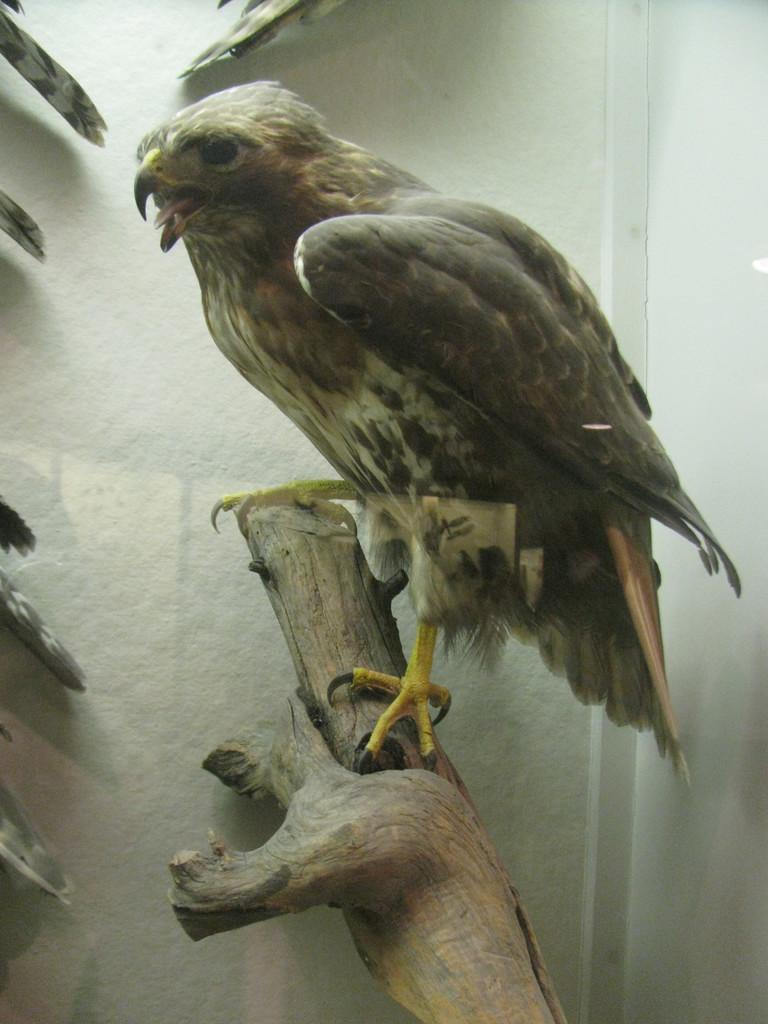What is the main subject in the image? There is a tree trunk in the image. Is there any living creature on the tree trunk? Yes, there is a grey-colored bird on the tree trunk. What can be seen in the background of the image? There is a white-colored wall in the background of the image. What type of trade is being conducted in the image? There is no indication of any trade being conducted in the image. Can you see any bones in the image? There are no bones visible in the image. 